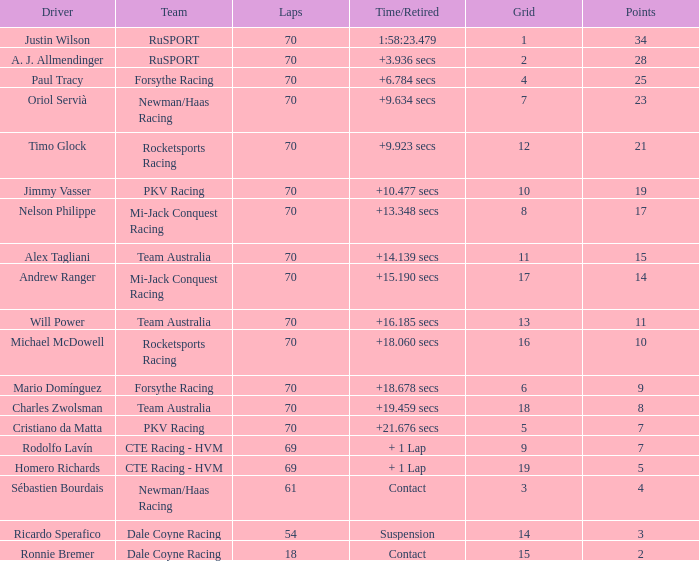Who accomplished a 10-grid score and the highest lap count? 70.0. 